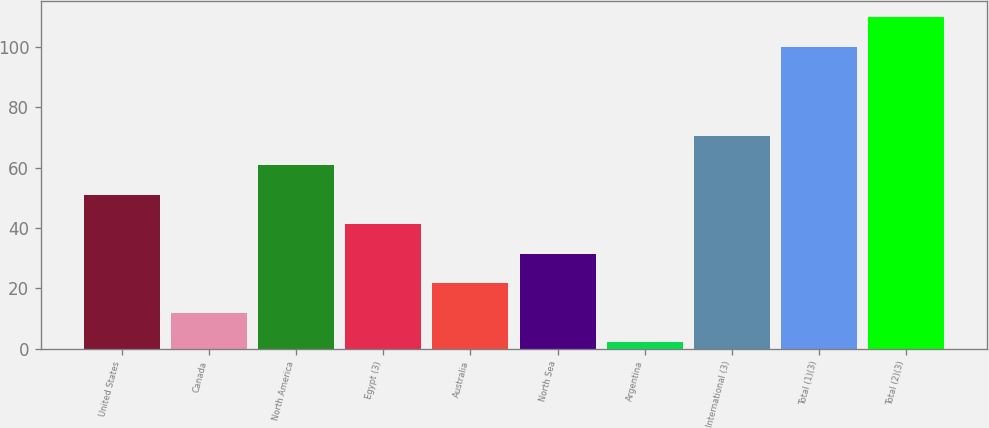Convert chart to OTSL. <chart><loc_0><loc_0><loc_500><loc_500><bar_chart><fcel>United States<fcel>Canada<fcel>North America<fcel>Egypt (3)<fcel>Australia<fcel>North Sea<fcel>Argentina<fcel>International (3)<fcel>Total (1)(3)<fcel>Total (2)(3)<nl><fcel>51<fcel>11.8<fcel>60.8<fcel>41.2<fcel>21.6<fcel>31.4<fcel>2<fcel>70.6<fcel>100<fcel>109.8<nl></chart> 